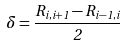Convert formula to latex. <formula><loc_0><loc_0><loc_500><loc_500>\delta = \frac { R _ { i , i + 1 } - R _ { i - 1 , i } } { 2 }</formula> 